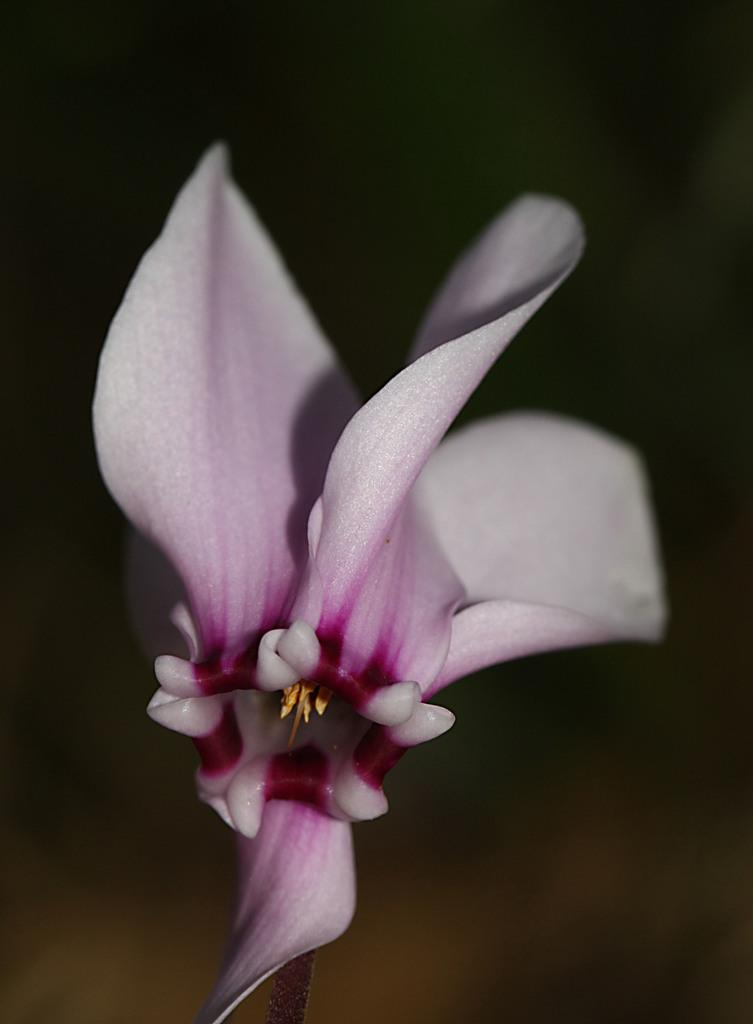What type of plant is present in the image? There is a flower in the image. What is the specific name of the flower? The name of the flower is cattleya. What hobbies does the flower enjoy in the image? The flower does not have hobbies, as it is a plant and not a living being with interests or activities. 